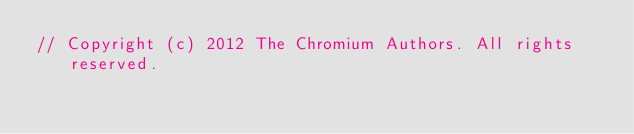Convert code to text. <code><loc_0><loc_0><loc_500><loc_500><_ObjectiveC_>// Copyright (c) 2012 The Chromium Authors. All rights reserved.</code> 